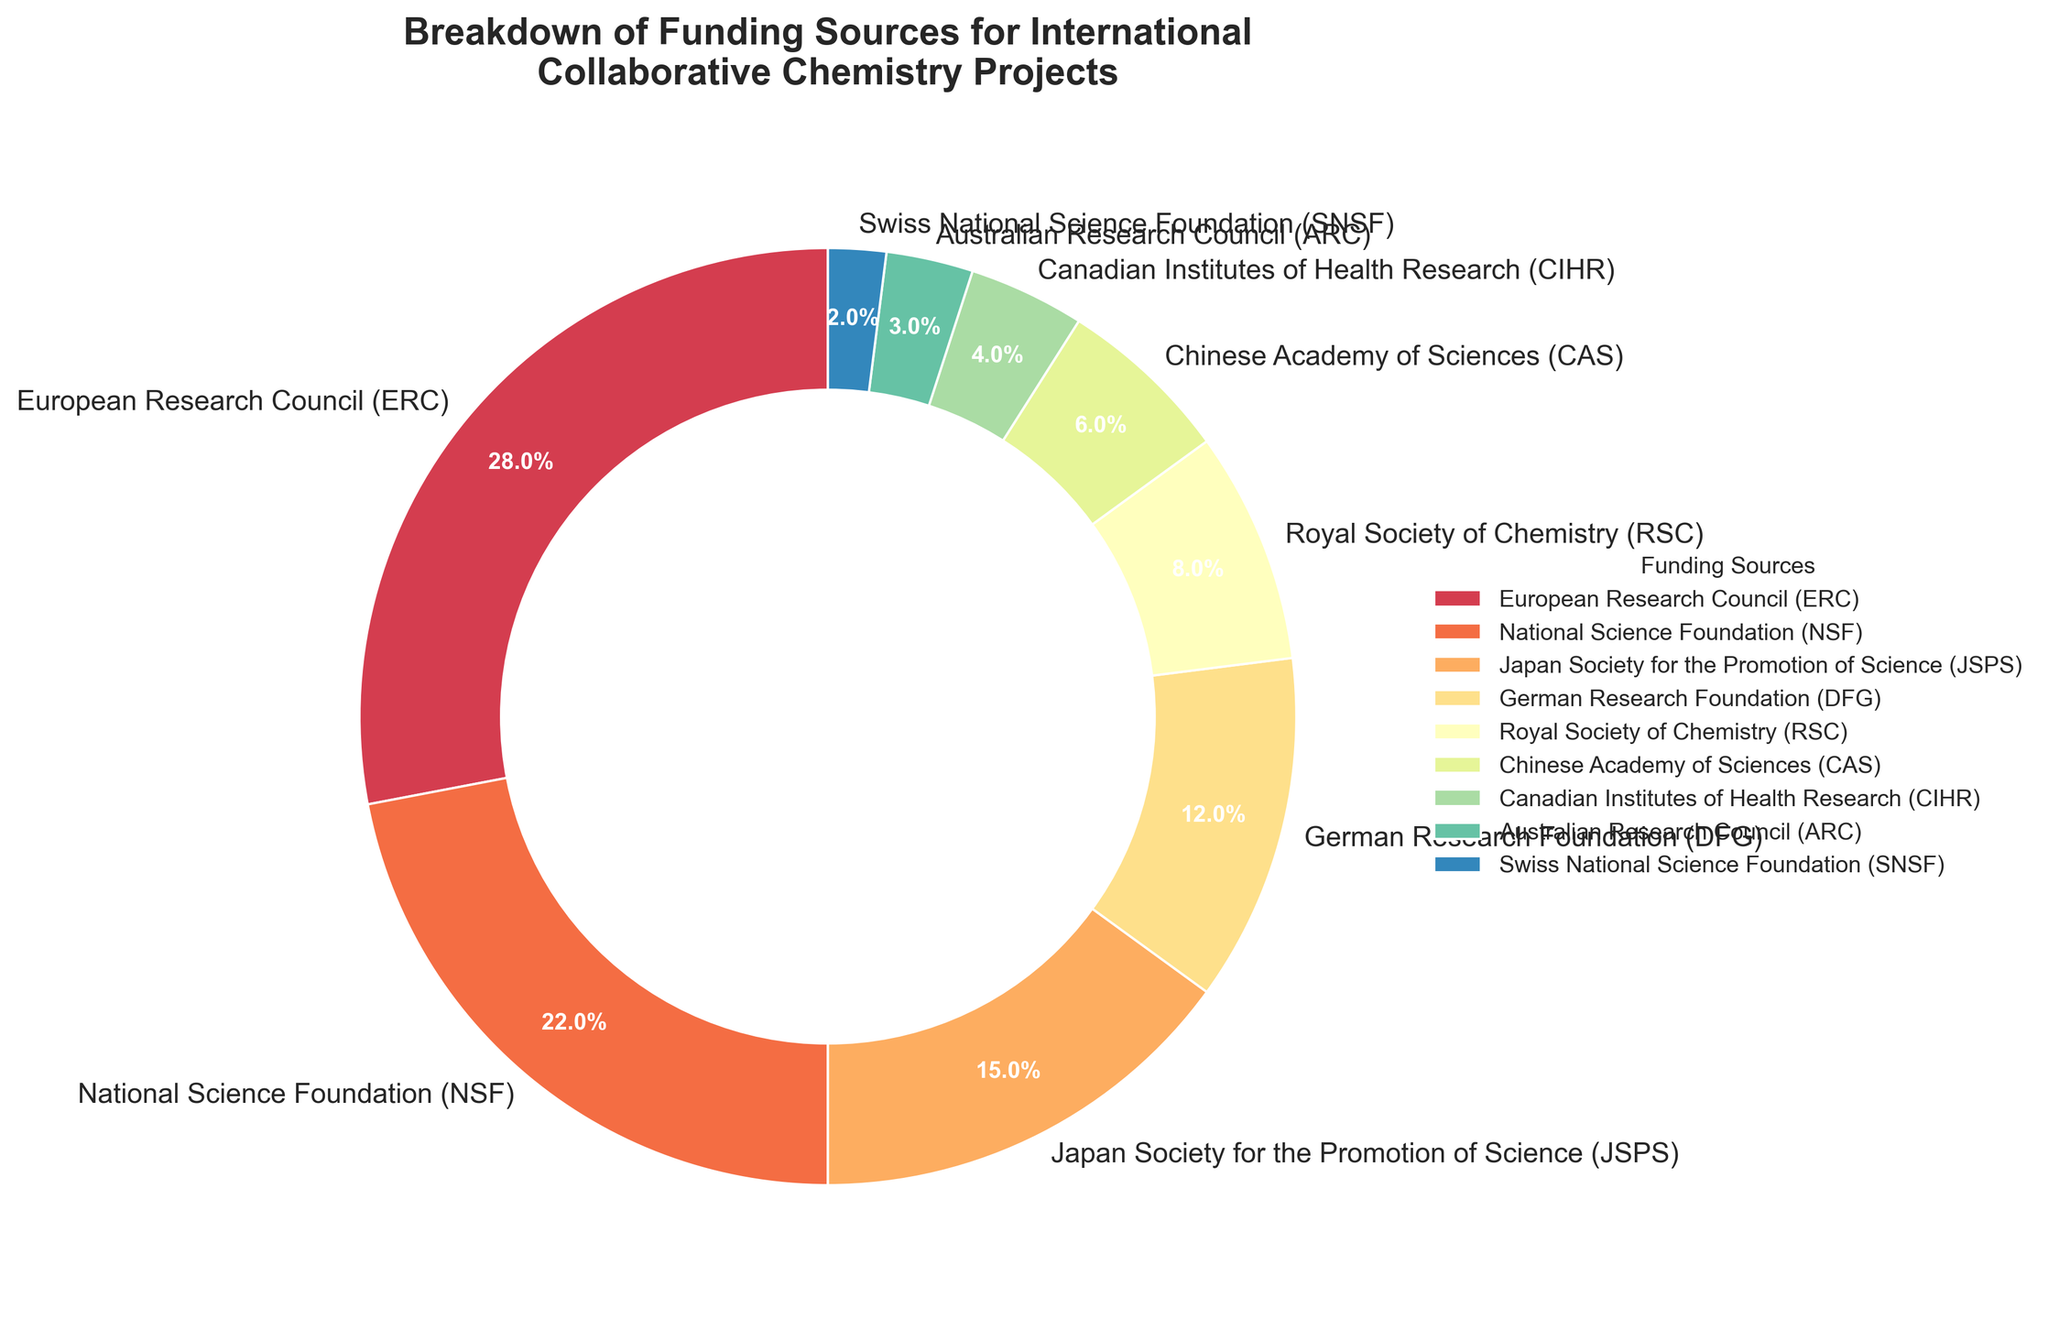Which funding source contributes the most to international collaborative chemistry projects? The wedge representing the European Research Council (ERC) is the largest in the pie chart.
Answer: European Research Council (ERC) How much more percentage does NSF contribute compared to JSPS? NSF's contribution is 22%, whereas JSPS's is 15%. The difference is calculated as 22% - 15% = 7%.
Answer: 7% What is the combined percentage contribution of DFG, RSC, and CAS? Adding up their contributions: DFG (12%) + RSC (8%) + CAS (6%) = 26%.
Answer: 26% Is RSC's contribution higher than 10%? The value for Royal Society of Chemistry (RSC) is clearly labeled as 8%, which is less than 10%.
Answer: No Which funding source contributes the least, and what is its percentage? The smallest wedge in the pie chart is labeled as SNSF with a 2% contribution.
Answer: SNSF, 2% What is the visual difference between the contribution of ERC and ARC? ERC's wedge is significantly larger at 28%, while ARC's wedge is much smaller at 3%.
Answer: ERC's wedge is significantly larger than ARC’s How many funding sources contribute less than 5% each? The wedges labeled CIHR, ARC, and SNSF contribute 4%, 3%, and 2% respectively. Thus, three funding sources contribute less than 5% each.
Answer: 3 Does the sum of contributions from JSPS, CAS, and CIHR exceed 20%? Adding their contributions: JSPS (15%) + CAS (6%) + CIHR (4%) gives a total of 25%, which exceeds 20%.
Answer: Yes Compare the contributions from European and non-European sources. Which group has a higher total percentage? Adding European sources: ERC (28%) + DFG (12%) + RSC (8%) + SNSF (2%) = 50%. Adding non-European sources: NSF (22%) + JSPS (15%) + CAS (6%) + CIHR (4%) + ARC (3%) = 50%. Both groups contribute equally.
Answer: Both groups have the same contribution, 50% If we were to combine the contributions of JSPS and CAS, would it be greater than the contribution of NSF? Adding JSPS (15%) and CAS (6%) gives us 21%, which is slightly less than NSF's 22%.
Answer: No 